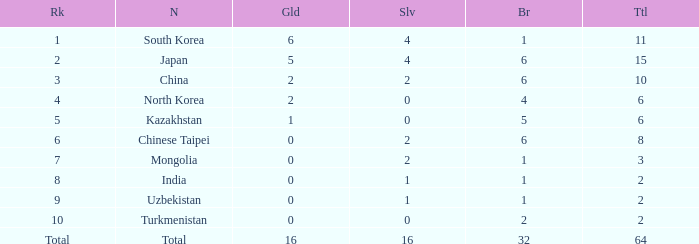What rank is Turkmenistan, who had 0 silver's and Less than 2 golds? 10.0. 